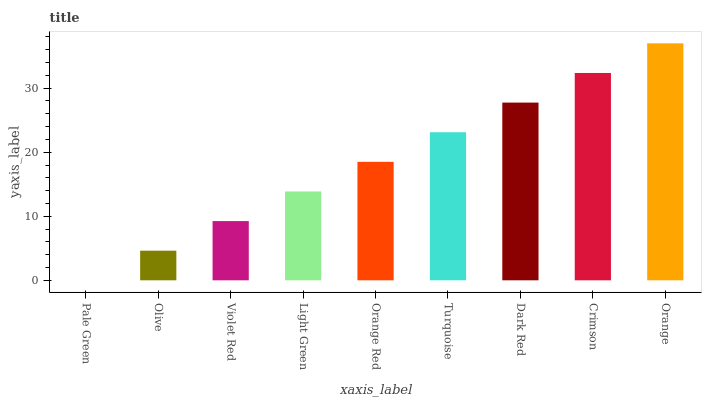Is Olive the minimum?
Answer yes or no. No. Is Olive the maximum?
Answer yes or no. No. Is Olive greater than Pale Green?
Answer yes or no. Yes. Is Pale Green less than Olive?
Answer yes or no. Yes. Is Pale Green greater than Olive?
Answer yes or no. No. Is Olive less than Pale Green?
Answer yes or no. No. Is Orange Red the high median?
Answer yes or no. Yes. Is Orange Red the low median?
Answer yes or no. Yes. Is Pale Green the high median?
Answer yes or no. No. Is Crimson the low median?
Answer yes or no. No. 